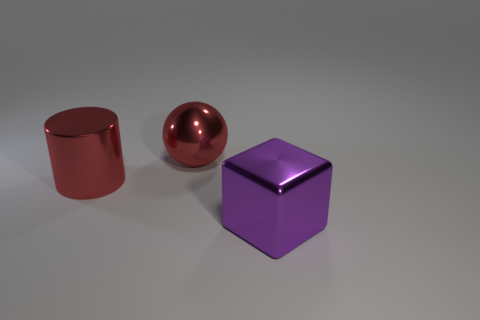There is a large metallic object behind the red cylinder; is it the same color as the shiny thing that is on the left side of the red shiny ball?
Ensure brevity in your answer.  Yes. Are there any other things that are the same color as the block?
Offer a terse response. No. There is a object in front of the red metallic thing in front of the sphere; what is its color?
Your answer should be very brief. Purple. How many big objects are either purple blocks or red things?
Keep it short and to the point. 3. Is there anything else that has the same material as the large red cylinder?
Ensure brevity in your answer.  Yes. What color is the cylinder?
Offer a very short reply. Red. Is the shiny cube the same color as the big metallic cylinder?
Give a very brief answer. No. How many large things are behind the large red metallic thing to the left of the big sphere?
Offer a very short reply. 1. What size is the shiny object that is in front of the sphere and on the right side of the large shiny cylinder?
Offer a terse response. Large. There is a big thing that is behind the large cylinder; what is its material?
Your answer should be compact. Metal. 